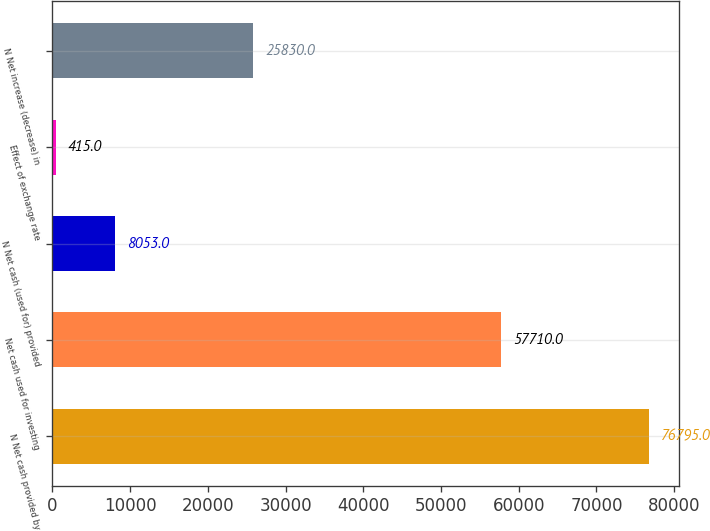Convert chart. <chart><loc_0><loc_0><loc_500><loc_500><bar_chart><fcel>N Net cash provided by<fcel>Net cash used for investing<fcel>N Net cash (used for) provided<fcel>Effect of exchange rate<fcel>N Net increase (decrease) in<nl><fcel>76795<fcel>57710<fcel>8053<fcel>415<fcel>25830<nl></chart> 